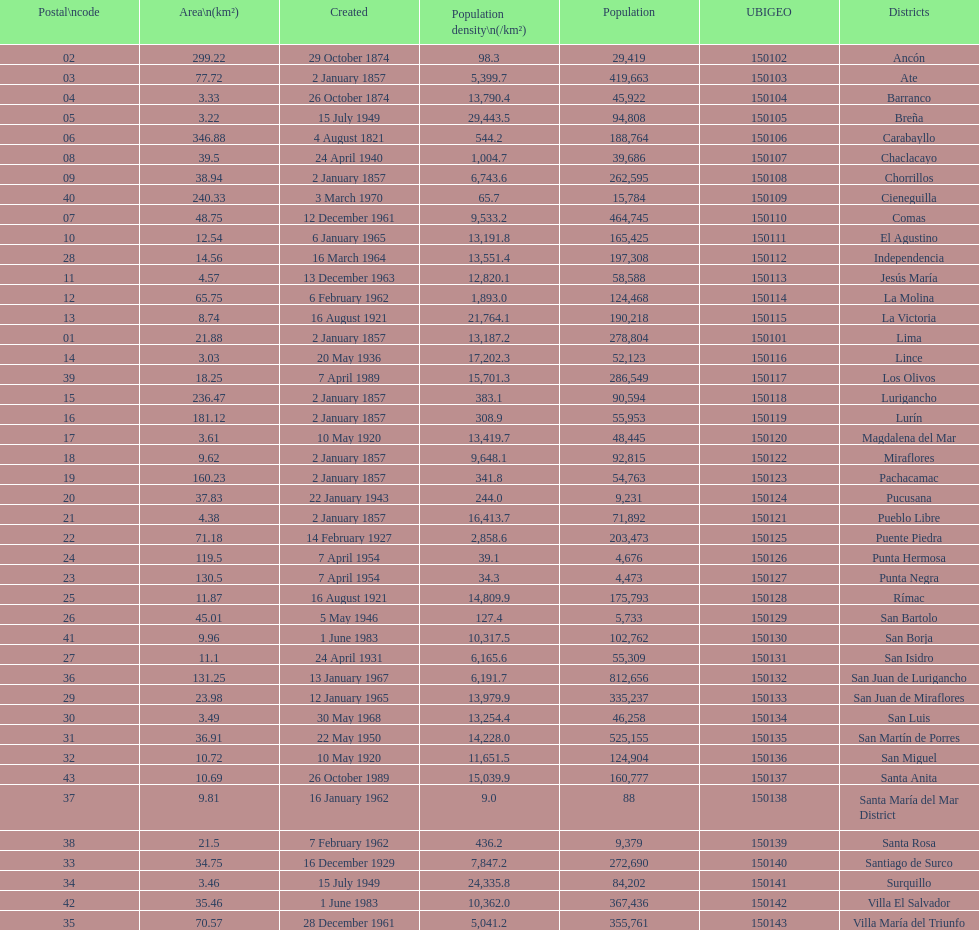How many districts are there in this city? 43. 